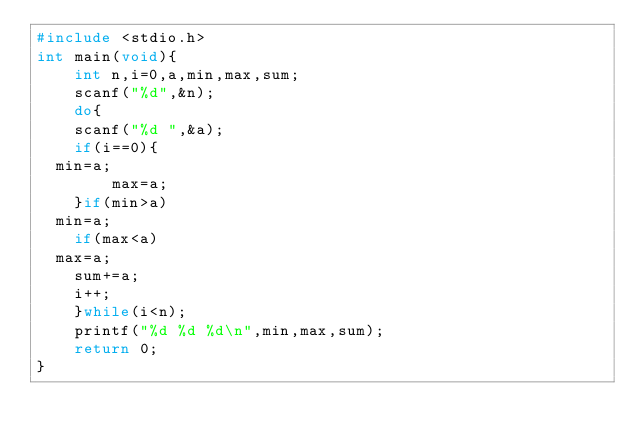<code> <loc_0><loc_0><loc_500><loc_500><_C_>#include <stdio.h>
int main(void){
    int n,i=0,a,min,max,sum;
    scanf("%d",&n);
    do{
    scanf("%d ",&a);
    if(i==0){
	min=a;
        max=a;
    }if(min>a)
	min=a;
    if(max<a)
	max=a;
    sum+=a;
    i++;
    }while(i<n);
    printf("%d %d %d\n",min,max,sum);
    return 0;
}</code> 